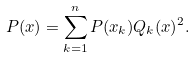<formula> <loc_0><loc_0><loc_500><loc_500>P ( x ) = \sum _ { k = 1 } ^ { n } P ( x _ { k } ) Q _ { k } ( x ) ^ { 2 } .</formula> 